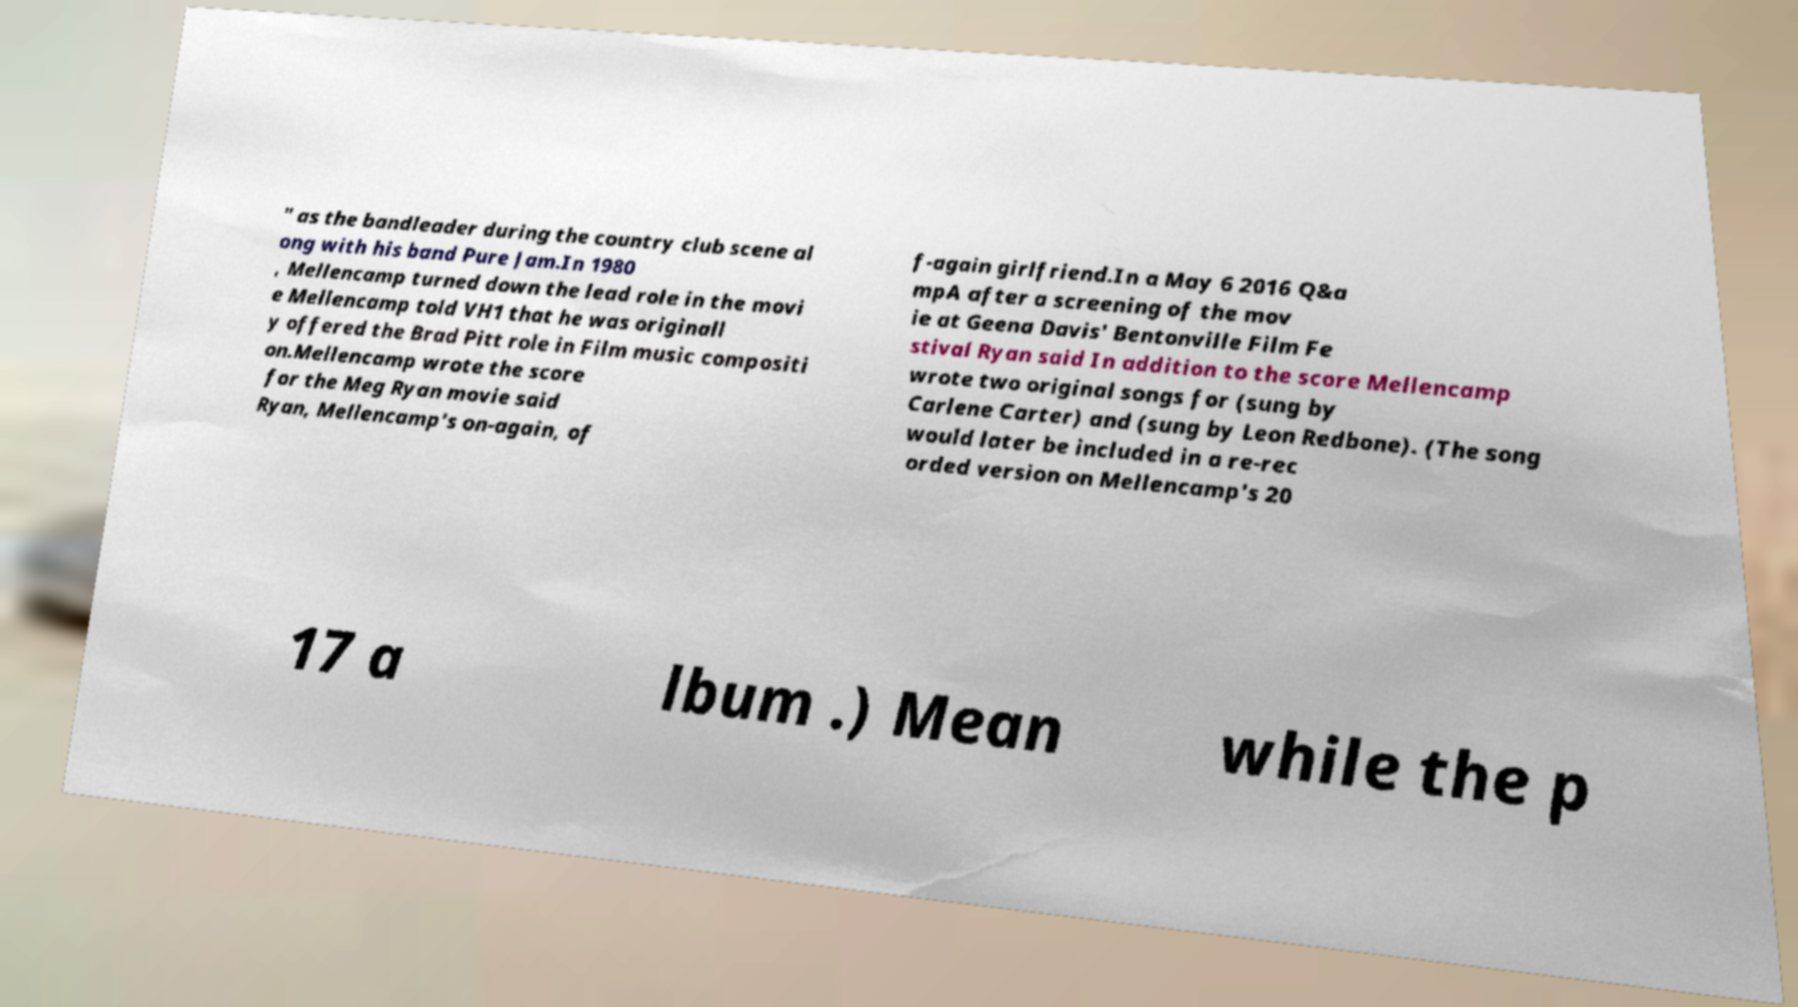Please identify and transcribe the text found in this image. " as the bandleader during the country club scene al ong with his band Pure Jam.In 1980 , Mellencamp turned down the lead role in the movi e Mellencamp told VH1 that he was originall y offered the Brad Pitt role in Film music compositi on.Mellencamp wrote the score for the Meg Ryan movie said Ryan, Mellencamp's on-again, of f-again girlfriend.In a May 6 2016 Q&a mpA after a screening of the mov ie at Geena Davis' Bentonville Film Fe stival Ryan said In addition to the score Mellencamp wrote two original songs for (sung by Carlene Carter) and (sung by Leon Redbone). (The song would later be included in a re-rec orded version on Mellencamp's 20 17 a lbum .) Mean while the p 